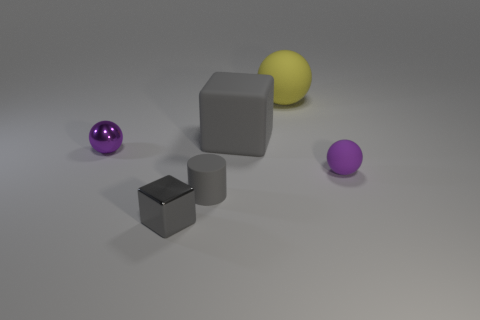How big is the purple rubber thing?
Provide a short and direct response. Small. What number of things are large green metal cubes or large gray rubber blocks?
Provide a short and direct response. 1. What color is the tiny ball that is made of the same material as the large gray object?
Your answer should be compact. Purple. Does the tiny thing right of the yellow matte object have the same shape as the yellow object?
Offer a terse response. Yes. How many objects are either large objects that are left of the large yellow rubber sphere or small purple objects left of the small metal block?
Your answer should be very brief. 2. There is another thing that is the same shape as the tiny gray metallic thing; what color is it?
Provide a succinct answer. Gray. Is there any other thing that has the same shape as the yellow matte thing?
Provide a succinct answer. Yes. Do the yellow matte thing and the tiny purple object that is right of the metallic cube have the same shape?
Keep it short and to the point. Yes. What is the material of the small gray cube?
Your response must be concise. Metal. There is another gray thing that is the same shape as the large gray thing; what size is it?
Your answer should be compact. Small. 